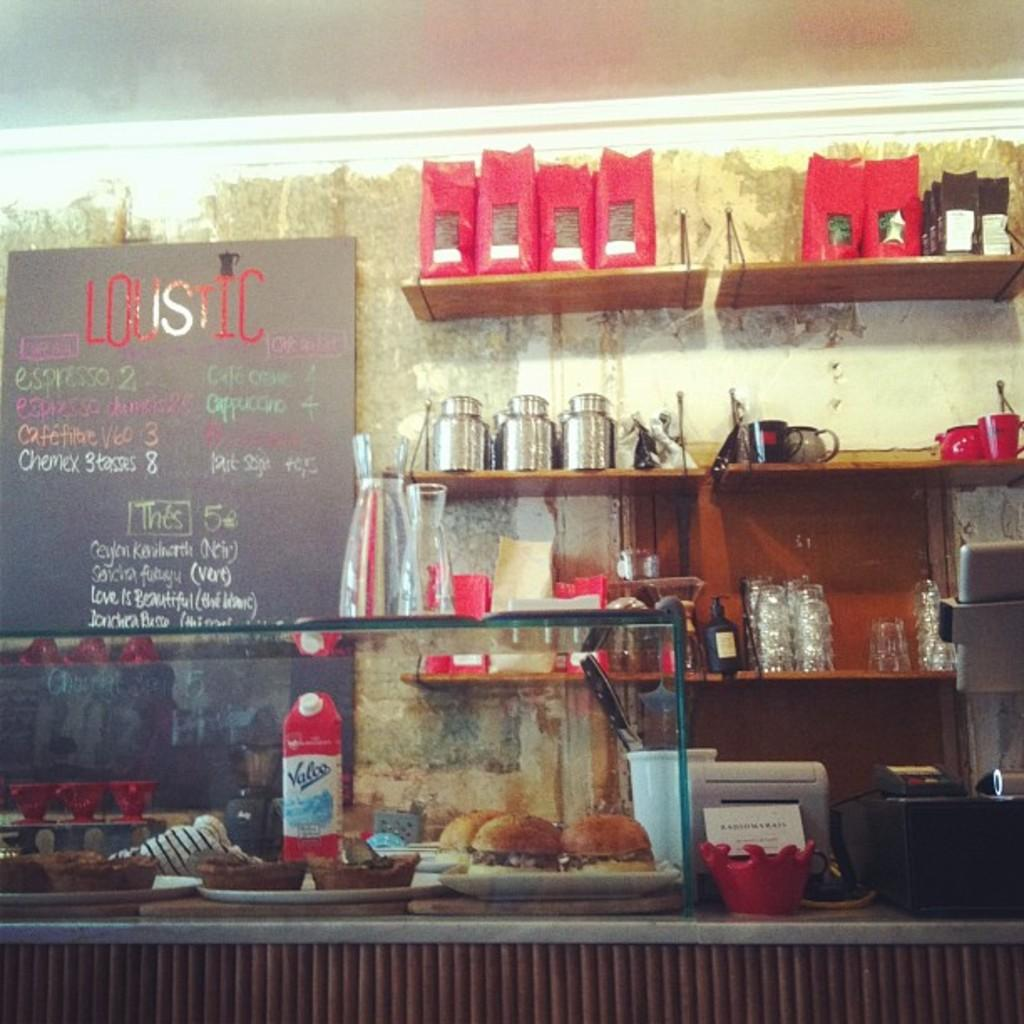Provide a one-sentence caption for the provided image. Loustic diner offers their specials on a board behind the counter. 